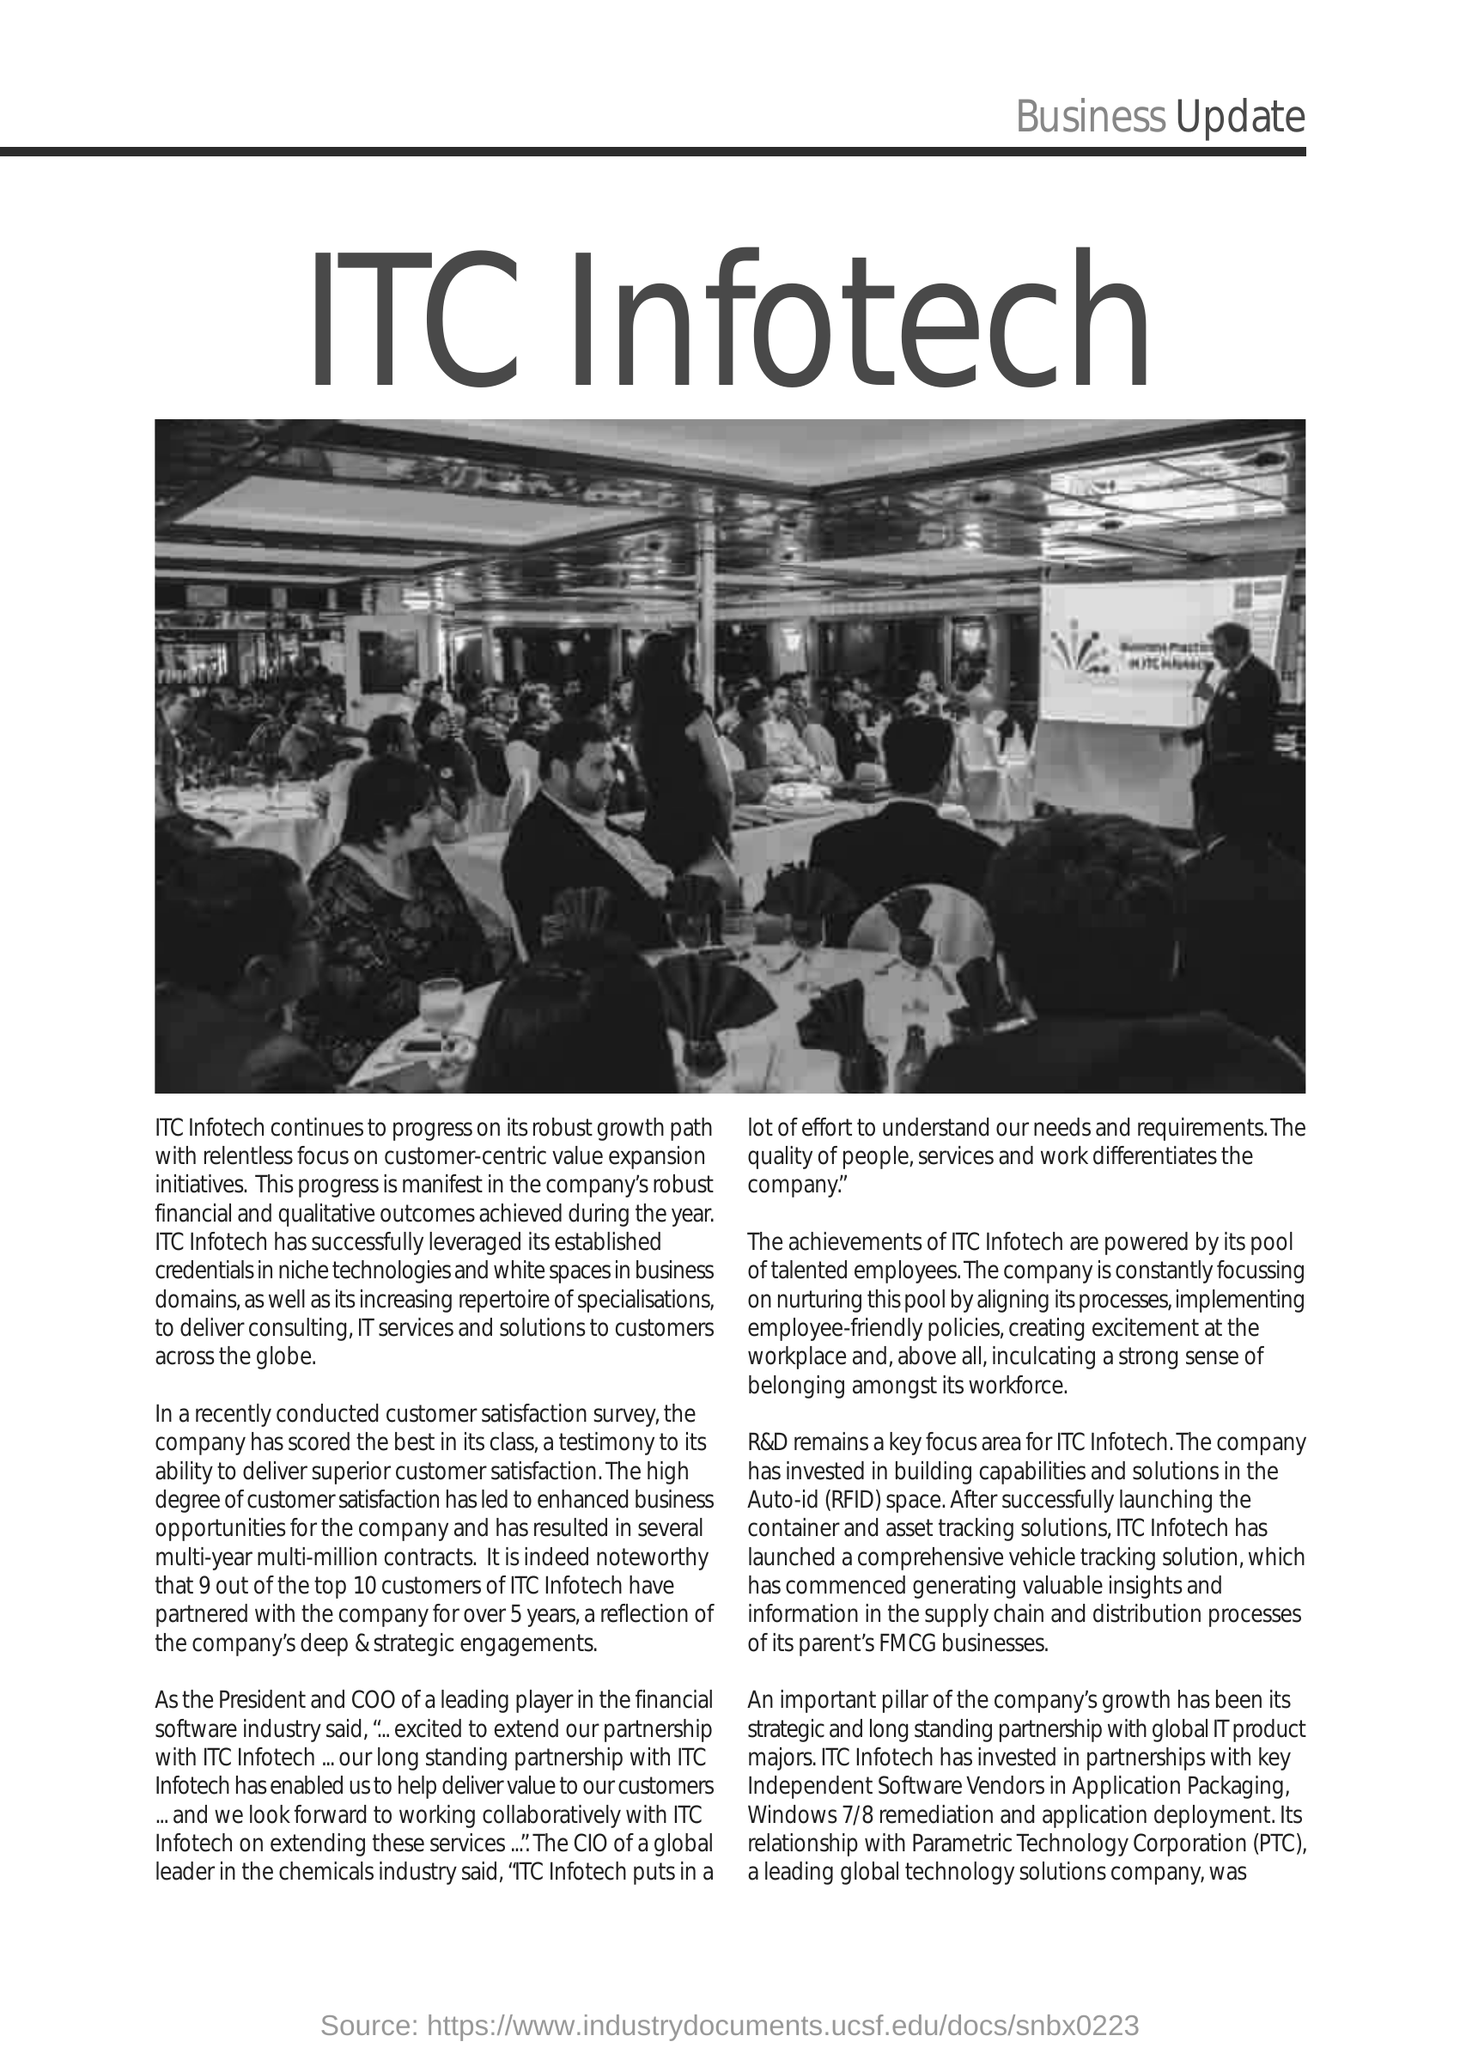Identify some key points in this picture. Parametric Technology Corporation, commonly known as PTC, is a company that specializes in computer-aided design, manufacturing, and product data management solutions. 